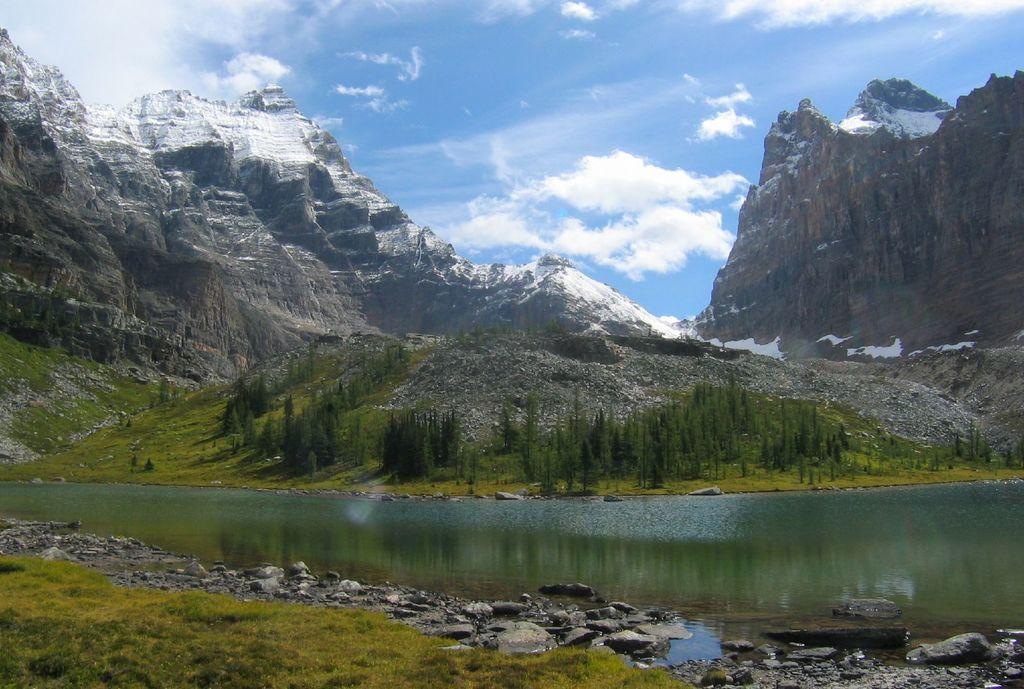Please provide a concise description of this image. In this image, we can see trees and mountains and at the bottom, there is water and we can see rocks. At the top, there are clouds in the sky. 